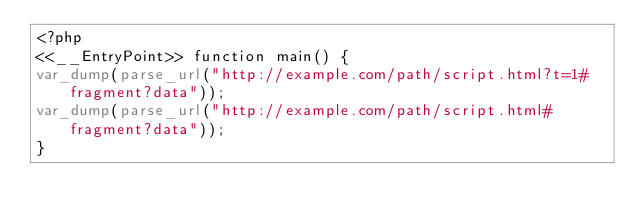Convert code to text. <code><loc_0><loc_0><loc_500><loc_500><_PHP_><?php
<<__EntryPoint>> function main() {
var_dump(parse_url("http://example.com/path/script.html?t=1#fragment?data"));
var_dump(parse_url("http://example.com/path/script.html#fragment?data"));
}
</code> 